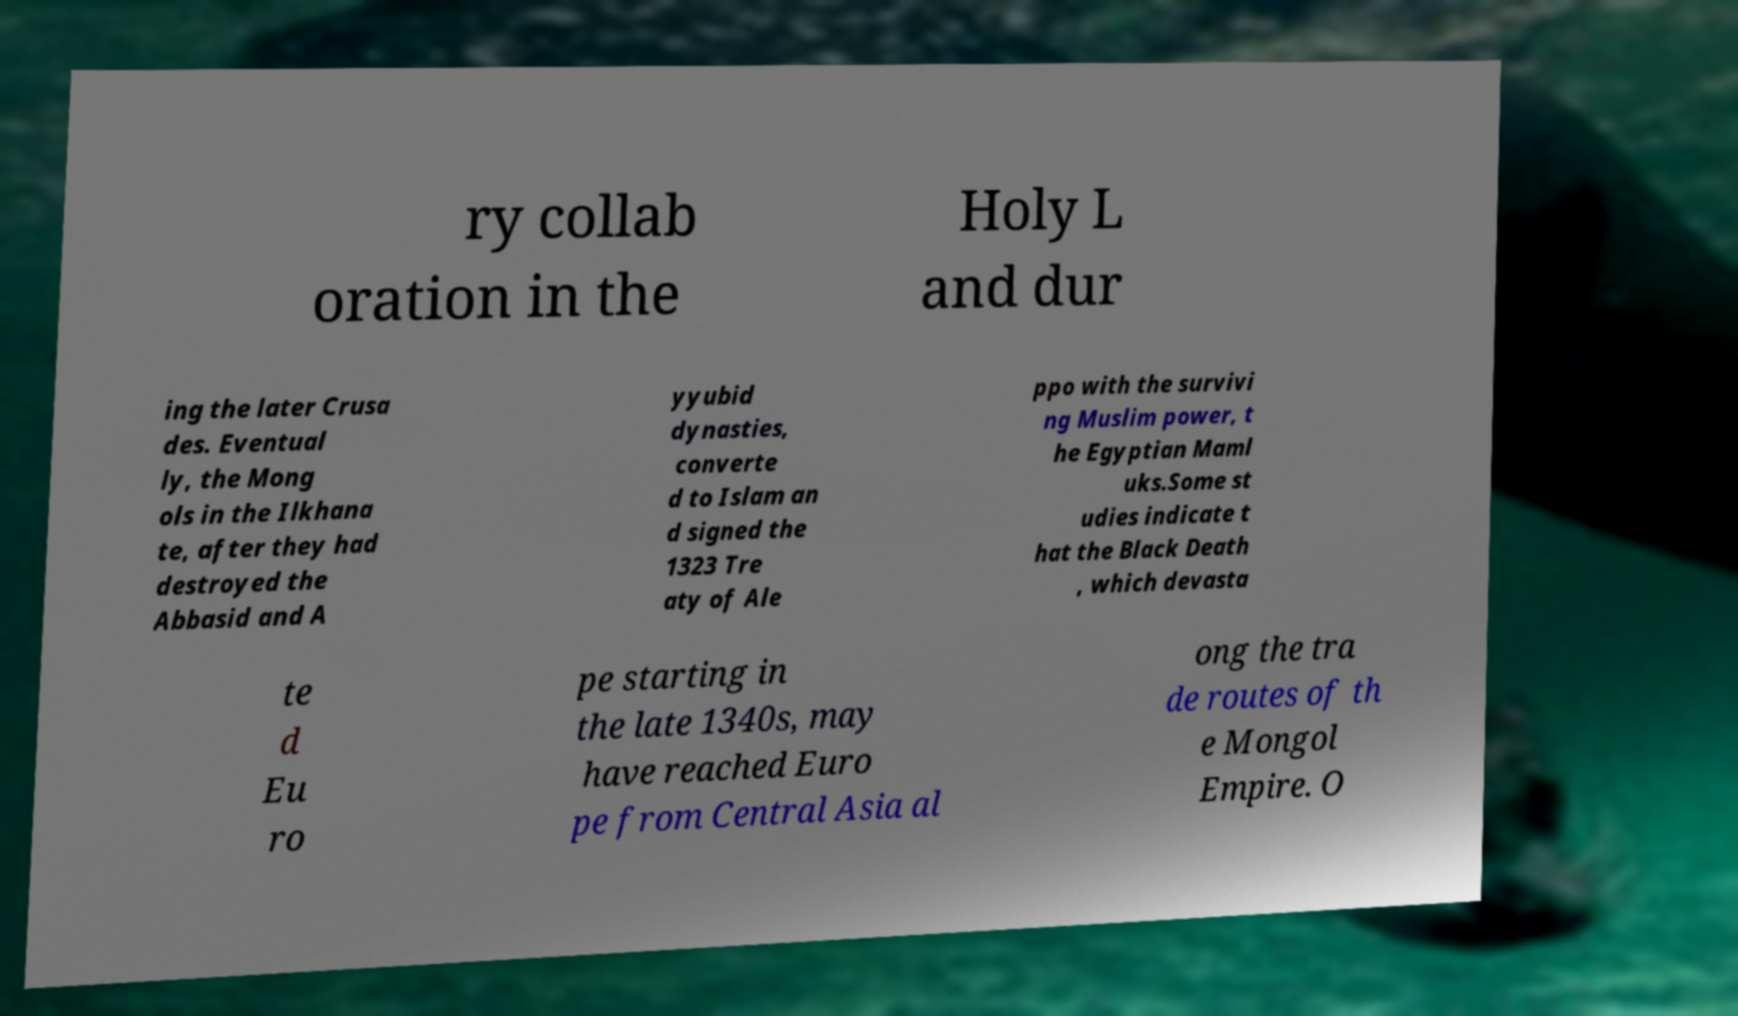Please read and relay the text visible in this image. What does it say? ry collab oration in the Holy L and dur ing the later Crusa des. Eventual ly, the Mong ols in the Ilkhana te, after they had destroyed the Abbasid and A yyubid dynasties, converte d to Islam an d signed the 1323 Tre aty of Ale ppo with the survivi ng Muslim power, t he Egyptian Maml uks.Some st udies indicate t hat the Black Death , which devasta te d Eu ro pe starting in the late 1340s, may have reached Euro pe from Central Asia al ong the tra de routes of th e Mongol Empire. O 